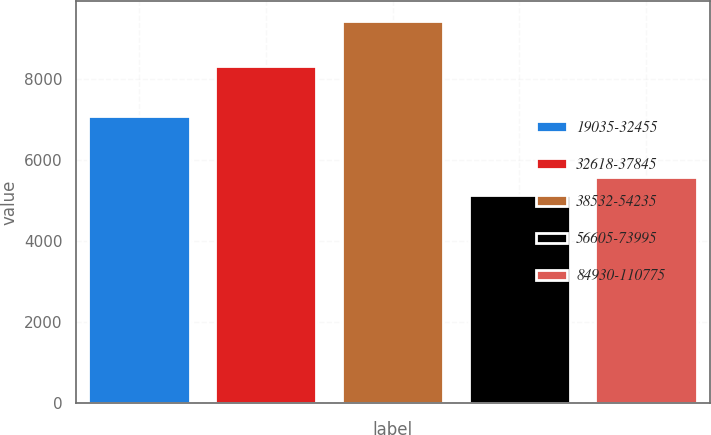Convert chart. <chart><loc_0><loc_0><loc_500><loc_500><bar_chart><fcel>19035-32455<fcel>32618-37845<fcel>38532-54235<fcel>56605-73995<fcel>84930-110775<nl><fcel>7081<fcel>8300<fcel>9431<fcel>5129<fcel>5559.2<nl></chart> 